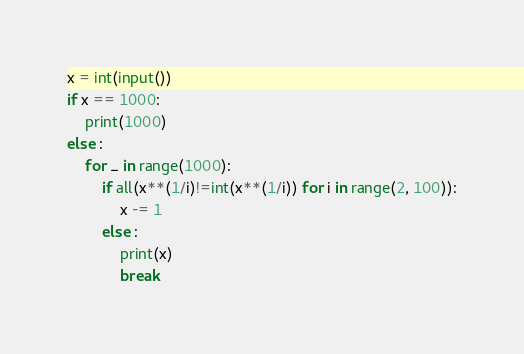Convert code to text. <code><loc_0><loc_0><loc_500><loc_500><_Python_>x = int(input())
if x == 1000:
    print(1000)
else :
    for _ in range(1000):
        if all(x**(1/i)!=int(x**(1/i)) for i in range(2, 100)):
            x -= 1
        else :
            print(x)
            break

</code> 